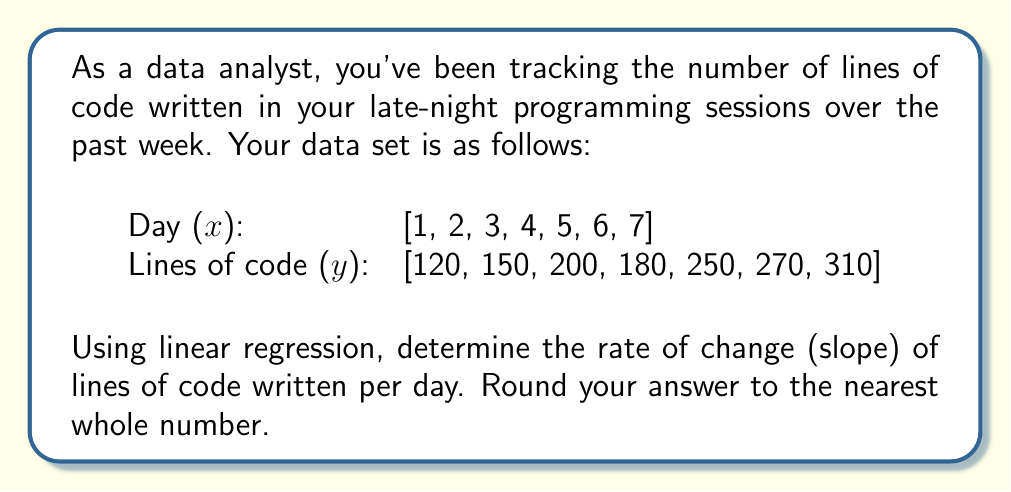Provide a solution to this math problem. To find the rate of change using linear regression, we'll follow these steps:

1) First, we need to calculate the means of x and y:
   $\bar{x} = \frac{1 + 2 + 3 + 4 + 5 + 6 + 7}{7} = 4$
   $\bar{y} = \frac{120 + 150 + 200 + 180 + 250 + 270 + 310}{7} = 211.43$

2) Now, we'll calculate the numerator and denominator of the slope formula:
   Slope $m = \frac{\sum(x_i - \bar{x})(y_i - \bar{y})}{\sum(x_i - \bar{x})^2}$

3) Let's calculate $\sum(x_i - \bar{x})(y_i - \bar{y})$:
   $$(1-4)(120-211.43) + (2-4)(150-211.43) + ... + (7-4)(310-211.43)$$
   $$= (-3)(-91.43) + (-2)(-61.43) + (-1)(-11.43) + (0)(-31.43) + (1)(38.57) + (2)(58.57) + (3)(98.57)$$
   $$= 274.29 + 122.86 + 11.43 + 0 + 38.57 + 117.14 + 295.71 = 860$$

4) Now, let's calculate $\sum(x_i - \bar{x})^2$:
   $$(-3)^2 + (-2)^2 + (-1)^2 + 0^2 + 1^2 + 2^2 + 3^2 = 28$$

5) Finally, we can calculate the slope:
   $$m = \frac{860}{28} = 30.71$$

6) Rounding to the nearest whole number:
   $$m \approx 31$$
Answer: 31 lines of code per day 